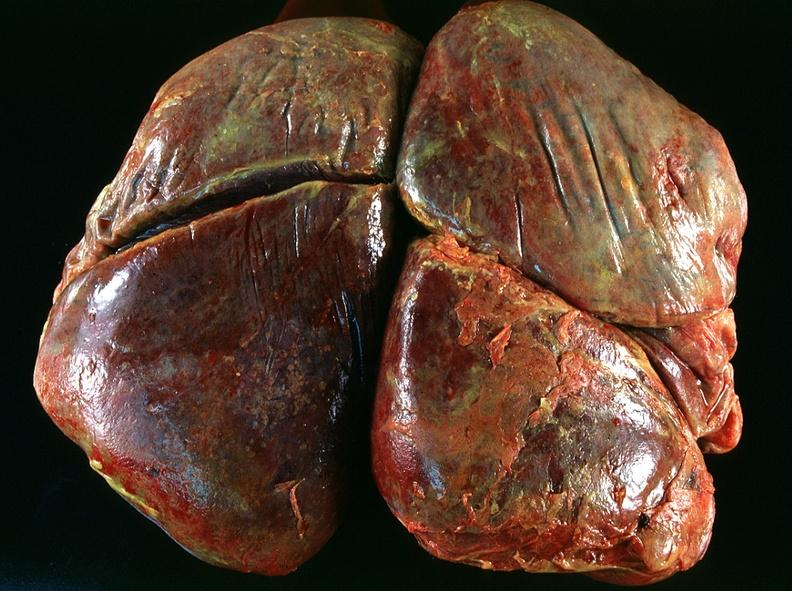what is present?
Answer the question using a single word or phrase. Respiratory 